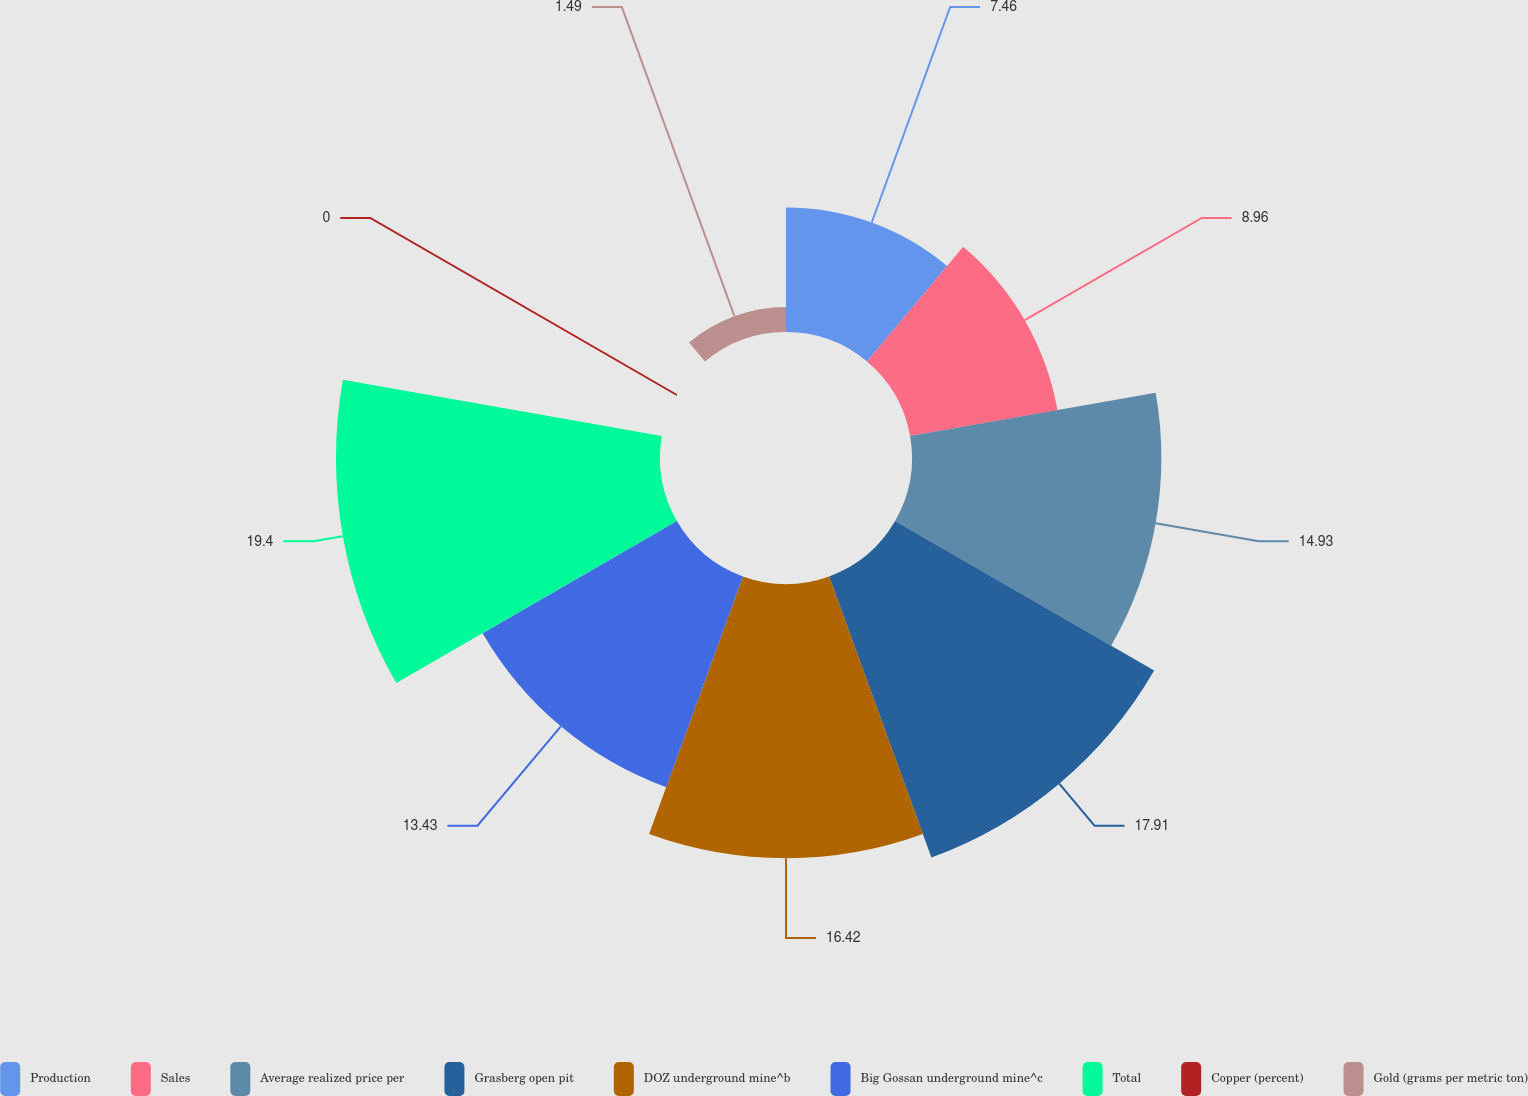<chart> <loc_0><loc_0><loc_500><loc_500><pie_chart><fcel>Production<fcel>Sales<fcel>Average realized price per<fcel>Grasberg open pit<fcel>DOZ underground mine^b<fcel>Big Gossan underground mine^c<fcel>Total<fcel>Copper (percent)<fcel>Gold (grams per metric ton)<nl><fcel>7.46%<fcel>8.96%<fcel>14.93%<fcel>17.91%<fcel>16.42%<fcel>13.43%<fcel>19.4%<fcel>0.0%<fcel>1.49%<nl></chart> 